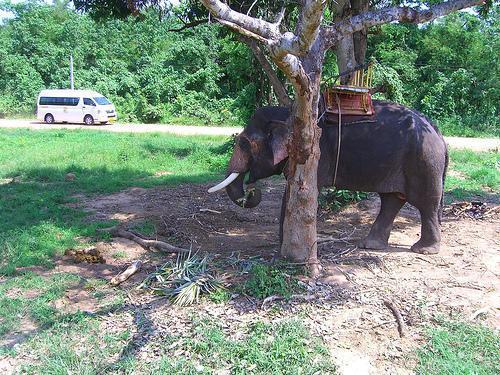How many elephants are there?
Give a very brief answer. 1. 